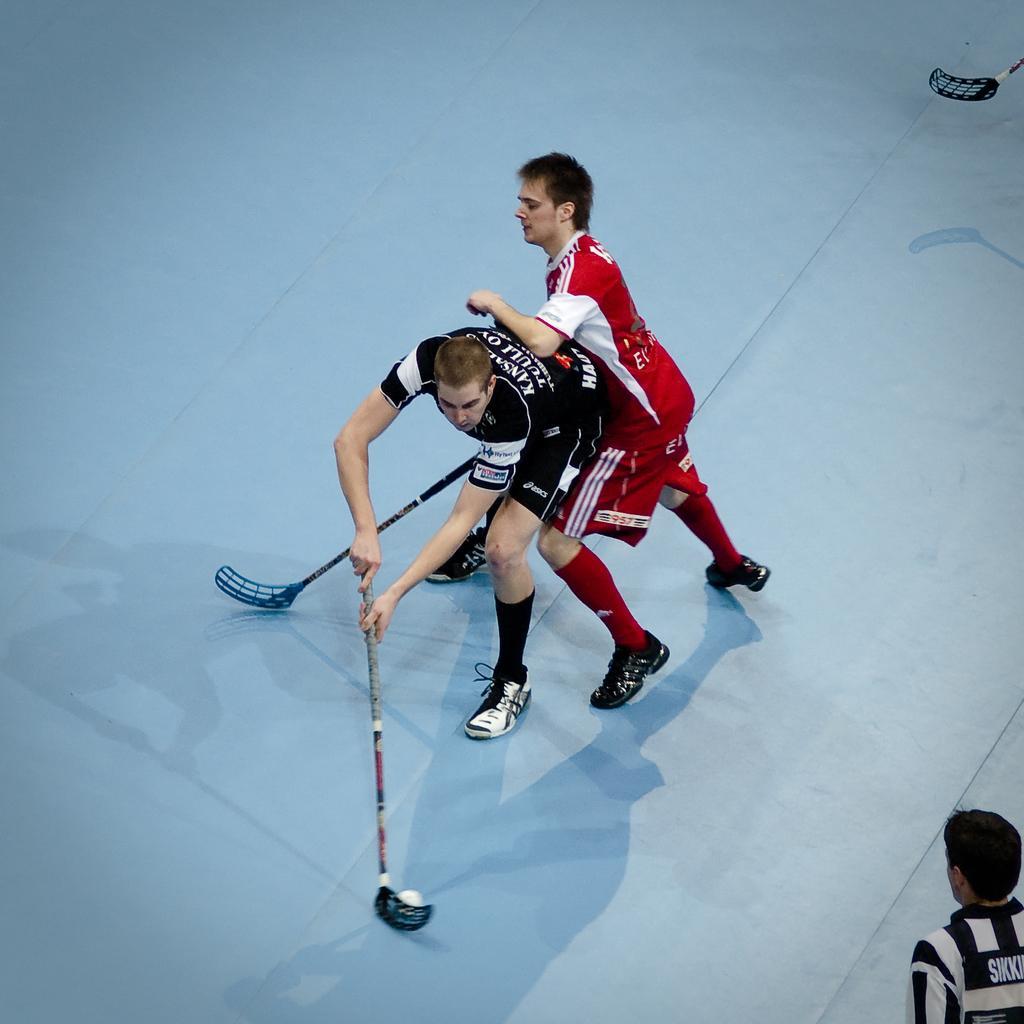Could you give a brief overview of what you see in this image? In the foreground of this picture, there are two men on the floor playing the floor ball. On the bottom right corner, there is a man and on the top, there is a bat. 